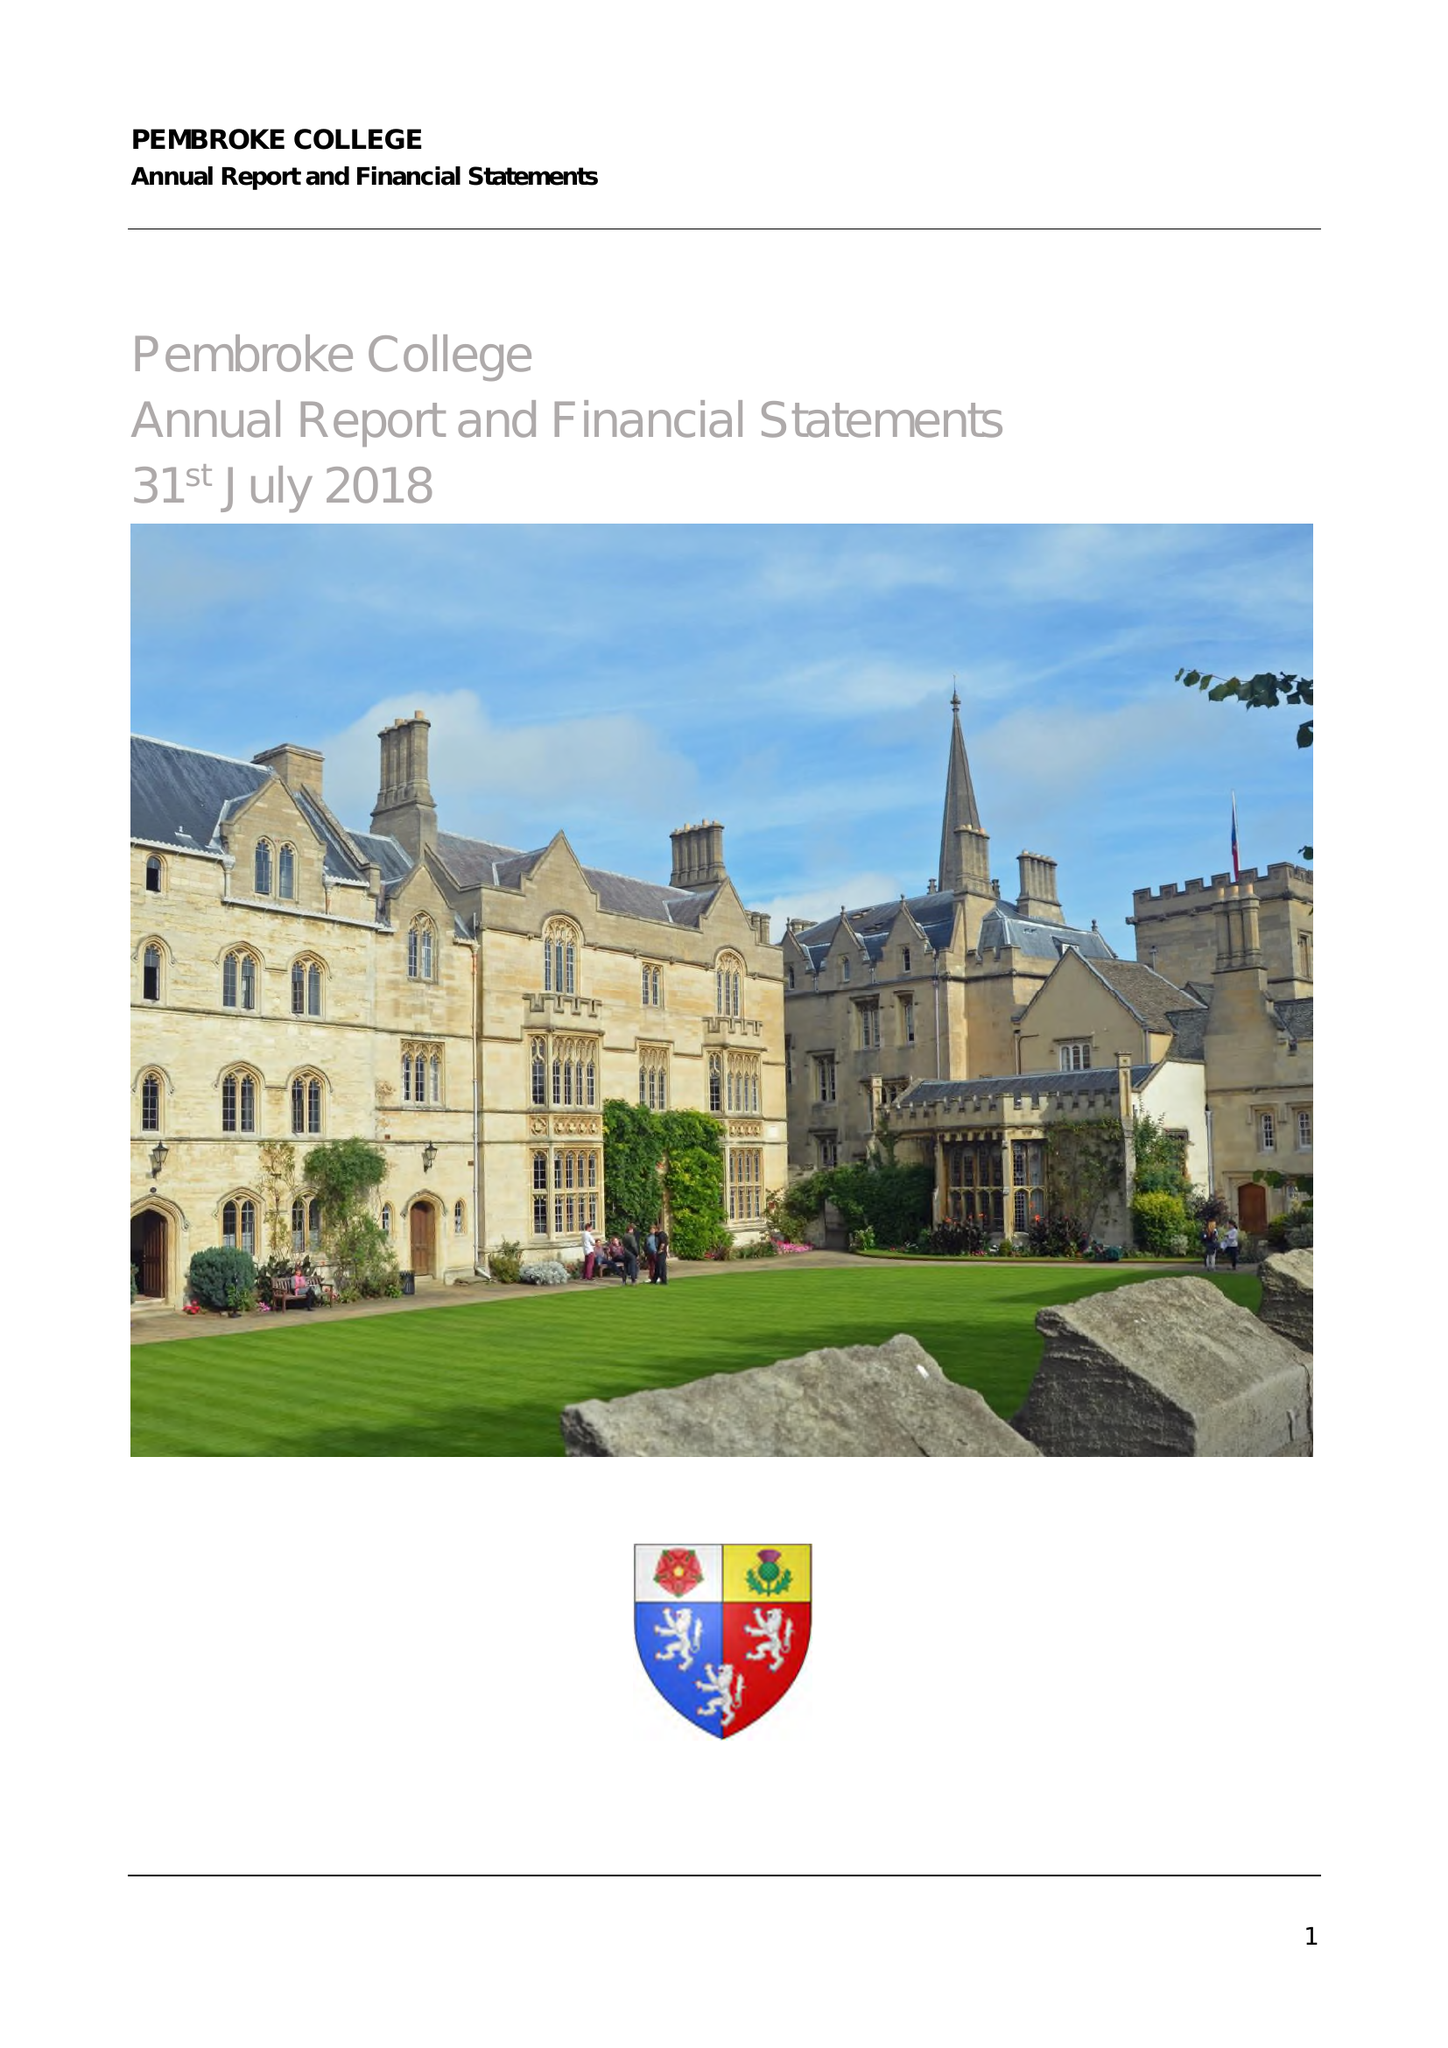What is the value for the address__postcode?
Answer the question using a single word or phrase. OX1 1DW 